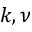<formula> <loc_0><loc_0><loc_500><loc_500>k , \nu</formula> 